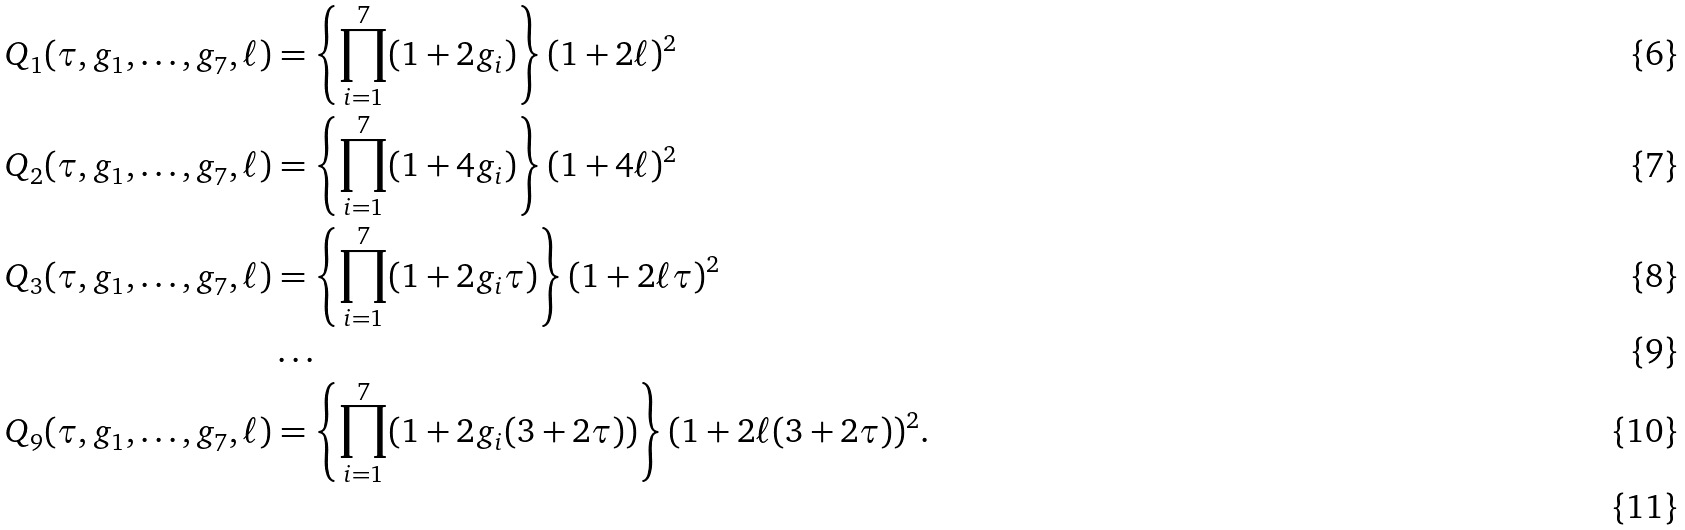<formula> <loc_0><loc_0><loc_500><loc_500>Q _ { 1 } ( \tau , g _ { 1 } , \dots , g _ { 7 } , \ell ) & = \left \{ \prod _ { i = 1 } ^ { 7 } ( 1 + 2 g _ { i } ) \right \} ( 1 + 2 \ell ) ^ { 2 } \\ Q _ { 2 } ( \tau , g _ { 1 } , \dots , g _ { 7 } , \ell ) & = \left \{ \prod _ { i = 1 } ^ { 7 } ( 1 + 4 g _ { i } ) \right \} ( 1 + 4 \ell ) ^ { 2 } \\ Q _ { 3 } ( \tau , g _ { 1 } , \dots , g _ { 7 } , \ell ) & = \left \{ \prod _ { i = 1 } ^ { 7 } ( 1 + 2 g _ { i } \tau ) \right \} ( 1 + 2 \ell \tau ) ^ { 2 } \\ & \dots \\ Q _ { 9 } ( \tau , g _ { 1 } , \dots , g _ { 7 } , \ell ) & = \left \{ \prod _ { i = 1 } ^ { 7 } ( 1 + 2 g _ { i } ( 3 + 2 \tau ) ) \right \} ( 1 + 2 \ell ( 3 + 2 \tau ) ) ^ { 2 } . \\</formula> 